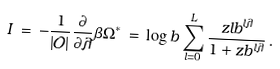Convert formula to latex. <formula><loc_0><loc_0><loc_500><loc_500>I \, = \, - \frac { 1 } { | { \mathcal { O } } | } \frac { \partial } { \partial \lambda } \beta \Omega ^ { * } \, = \, \log b \sum _ { l = 0 } ^ { L } \frac { z l b ^ { l \lambda } } { 1 + z b ^ { l \lambda } } \, .</formula> 